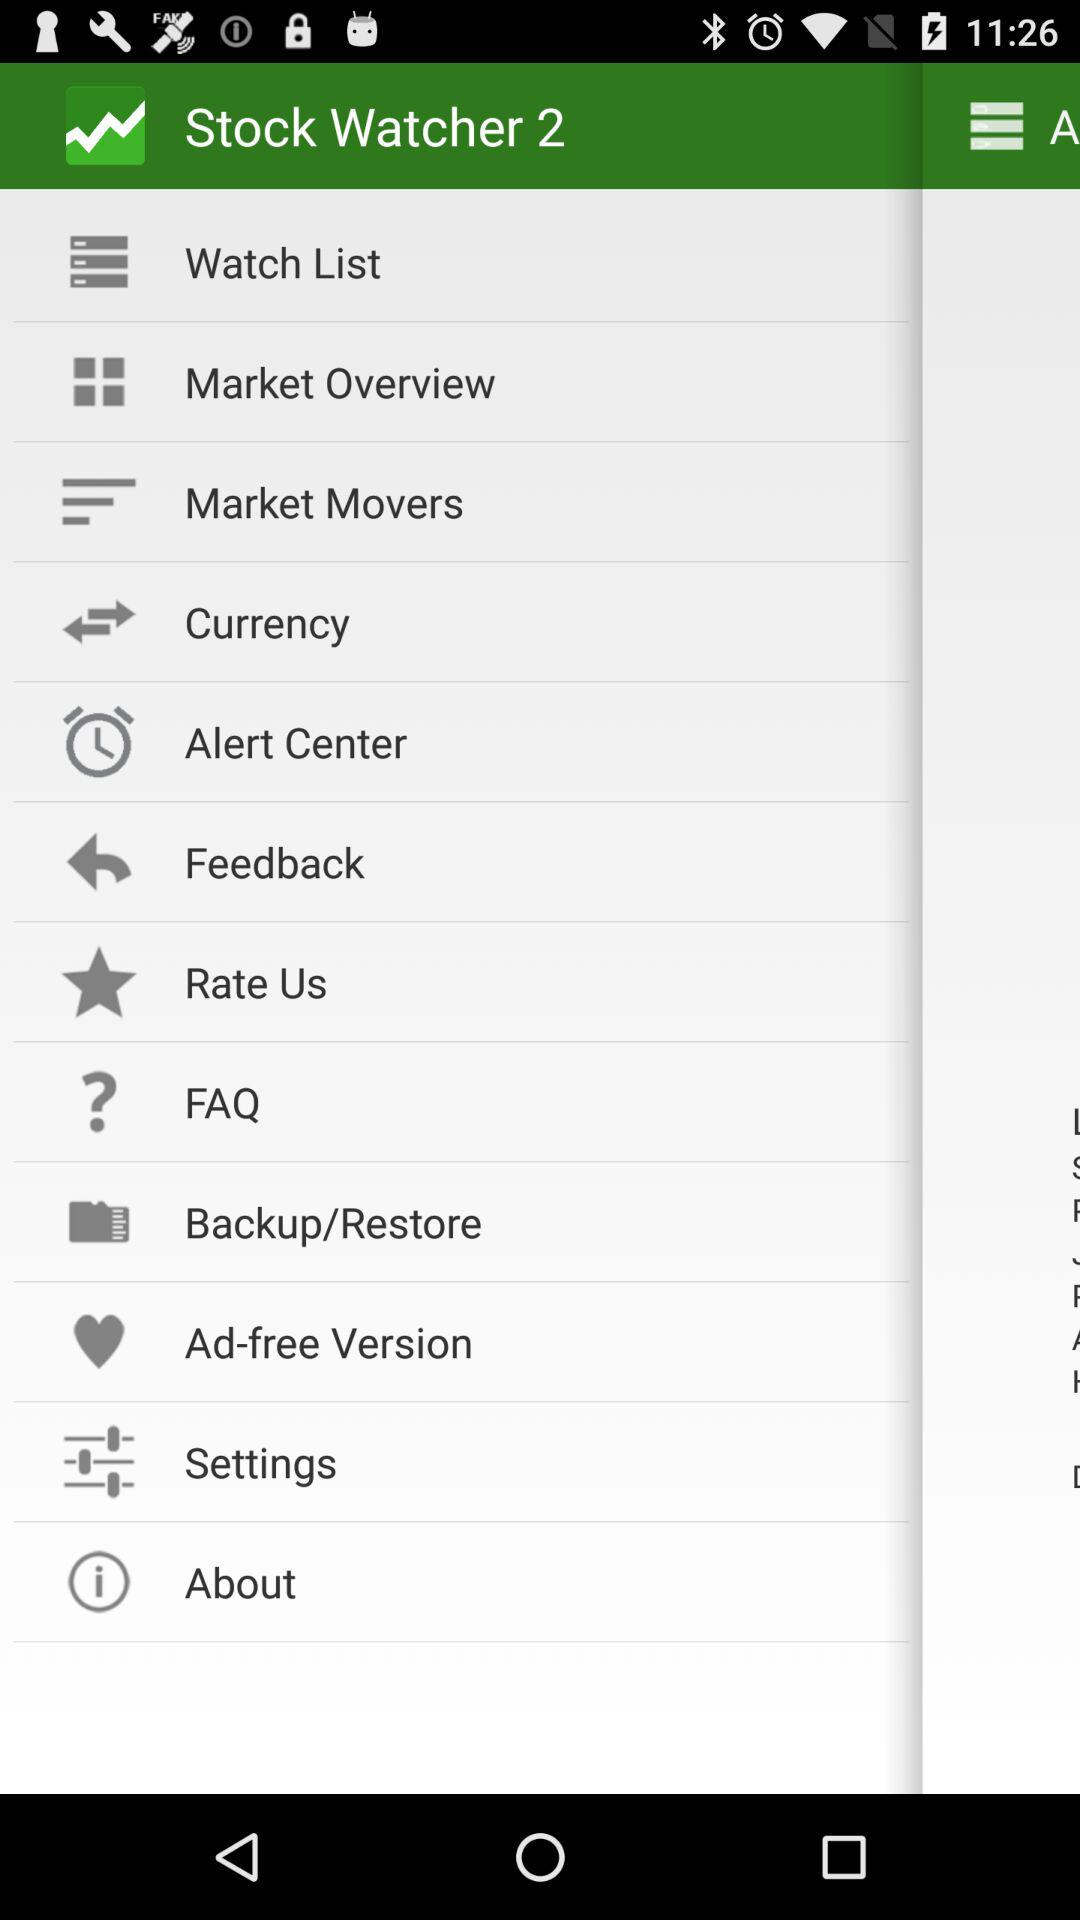What is the app name? The app name is "Stock Watcher 2". 